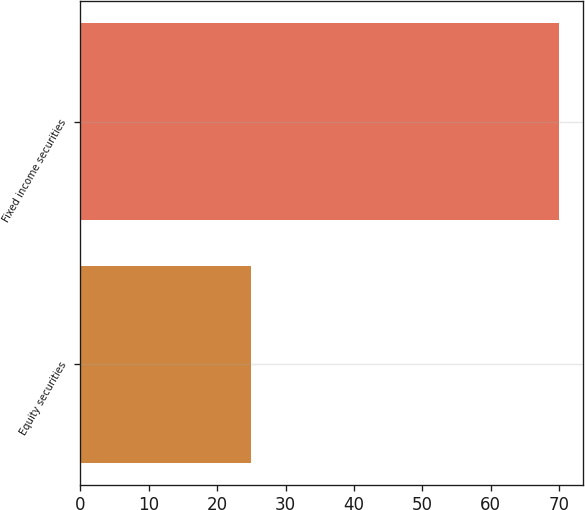<chart> <loc_0><loc_0><loc_500><loc_500><bar_chart><fcel>Equity securities<fcel>Fixed income securities<nl><fcel>25<fcel>70<nl></chart> 